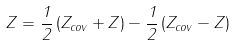Convert formula to latex. <formula><loc_0><loc_0><loc_500><loc_500>Z = \frac { 1 } { 2 } \left ( Z _ { c o v } + Z \right ) - \frac { 1 } { 2 } \left ( Z _ { c o v } - Z \right )</formula> 